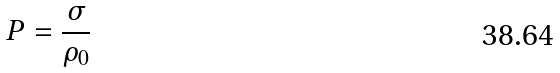Convert formula to latex. <formula><loc_0><loc_0><loc_500><loc_500>P = \frac { \sigma } { \rho _ { 0 } }</formula> 